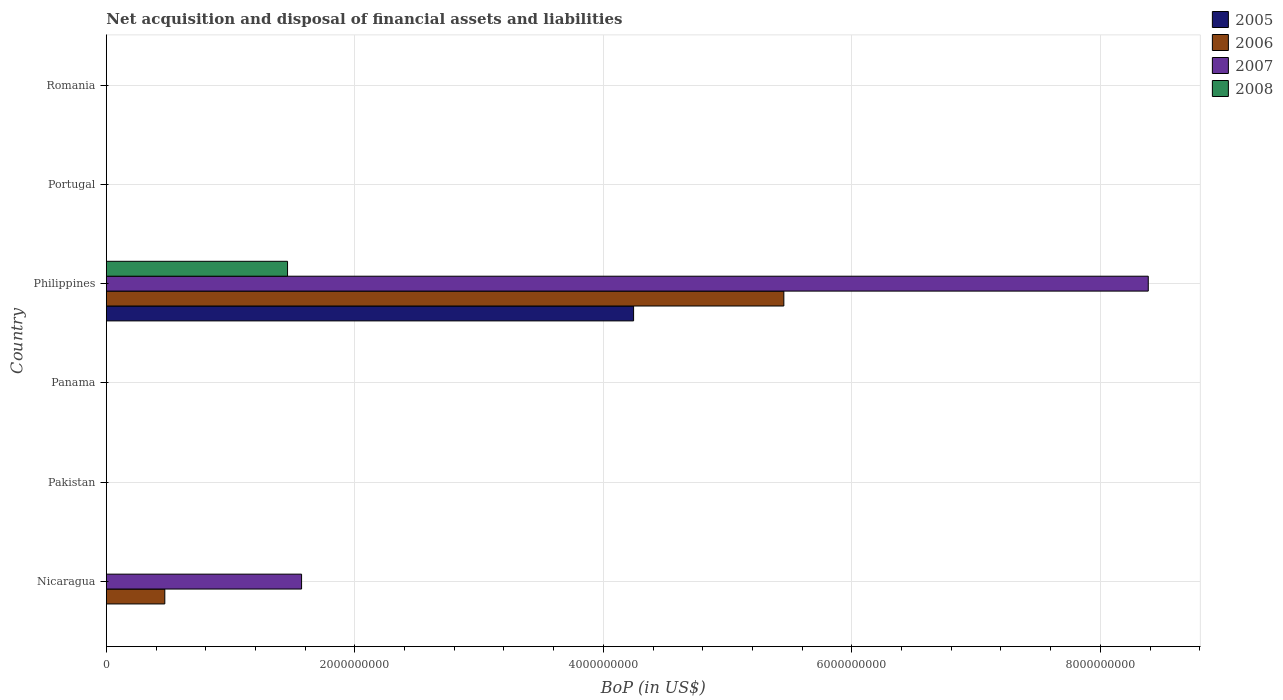Are the number of bars on each tick of the Y-axis equal?
Provide a short and direct response. No. How many bars are there on the 5th tick from the top?
Provide a short and direct response. 0. How many bars are there on the 2nd tick from the bottom?
Offer a very short reply. 0. What is the label of the 6th group of bars from the top?
Ensure brevity in your answer.  Nicaragua. In how many cases, is the number of bars for a given country not equal to the number of legend labels?
Give a very brief answer. 5. What is the Balance of Payments in 2008 in Romania?
Your answer should be very brief. 0. Across all countries, what is the maximum Balance of Payments in 2008?
Your answer should be compact. 1.46e+09. What is the total Balance of Payments in 2006 in the graph?
Offer a very short reply. 5.92e+09. What is the difference between the Balance of Payments in 2008 in Romania and the Balance of Payments in 2005 in Panama?
Offer a terse response. 0. What is the average Balance of Payments in 2006 per country?
Ensure brevity in your answer.  9.87e+08. What is the difference between the Balance of Payments in 2005 and Balance of Payments in 2008 in Philippines?
Provide a short and direct response. 2.79e+09. What is the difference between the highest and the lowest Balance of Payments in 2005?
Your response must be concise. 4.24e+09. In how many countries, is the Balance of Payments in 2007 greater than the average Balance of Payments in 2007 taken over all countries?
Offer a terse response. 1. Is the sum of the Balance of Payments in 2007 in Nicaragua and Philippines greater than the maximum Balance of Payments in 2006 across all countries?
Your answer should be very brief. Yes. How many bars are there?
Provide a short and direct response. 6. What is the difference between two consecutive major ticks on the X-axis?
Offer a very short reply. 2.00e+09. Does the graph contain grids?
Ensure brevity in your answer.  Yes. How many legend labels are there?
Give a very brief answer. 4. What is the title of the graph?
Keep it short and to the point. Net acquisition and disposal of financial assets and liabilities. What is the label or title of the X-axis?
Your answer should be compact. BoP (in US$). What is the BoP (in US$) in 2006 in Nicaragua?
Make the answer very short. 4.71e+08. What is the BoP (in US$) in 2007 in Nicaragua?
Your response must be concise. 1.57e+09. What is the BoP (in US$) in 2006 in Pakistan?
Keep it short and to the point. 0. What is the BoP (in US$) of 2007 in Pakistan?
Your answer should be compact. 0. What is the BoP (in US$) of 2008 in Pakistan?
Your answer should be very brief. 0. What is the BoP (in US$) of 2005 in Panama?
Offer a very short reply. 0. What is the BoP (in US$) of 2007 in Panama?
Offer a terse response. 0. What is the BoP (in US$) of 2005 in Philippines?
Your answer should be compact. 4.24e+09. What is the BoP (in US$) of 2006 in Philippines?
Offer a very short reply. 5.45e+09. What is the BoP (in US$) in 2007 in Philippines?
Provide a short and direct response. 8.39e+09. What is the BoP (in US$) of 2008 in Philippines?
Offer a terse response. 1.46e+09. What is the BoP (in US$) of 2007 in Portugal?
Make the answer very short. 0. What is the BoP (in US$) in 2007 in Romania?
Make the answer very short. 0. What is the BoP (in US$) in 2008 in Romania?
Offer a terse response. 0. Across all countries, what is the maximum BoP (in US$) of 2005?
Offer a very short reply. 4.24e+09. Across all countries, what is the maximum BoP (in US$) of 2006?
Provide a short and direct response. 5.45e+09. Across all countries, what is the maximum BoP (in US$) of 2007?
Provide a succinct answer. 8.39e+09. Across all countries, what is the maximum BoP (in US$) in 2008?
Your response must be concise. 1.46e+09. Across all countries, what is the minimum BoP (in US$) in 2007?
Offer a very short reply. 0. What is the total BoP (in US$) in 2005 in the graph?
Provide a succinct answer. 4.24e+09. What is the total BoP (in US$) in 2006 in the graph?
Your answer should be very brief. 5.92e+09. What is the total BoP (in US$) of 2007 in the graph?
Make the answer very short. 9.96e+09. What is the total BoP (in US$) of 2008 in the graph?
Provide a succinct answer. 1.46e+09. What is the difference between the BoP (in US$) in 2006 in Nicaragua and that in Philippines?
Your answer should be very brief. -4.98e+09. What is the difference between the BoP (in US$) of 2007 in Nicaragua and that in Philippines?
Provide a succinct answer. -6.81e+09. What is the difference between the BoP (in US$) in 2006 in Nicaragua and the BoP (in US$) in 2007 in Philippines?
Make the answer very short. -7.91e+09. What is the difference between the BoP (in US$) in 2006 in Nicaragua and the BoP (in US$) in 2008 in Philippines?
Make the answer very short. -9.88e+08. What is the difference between the BoP (in US$) in 2007 in Nicaragua and the BoP (in US$) in 2008 in Philippines?
Your answer should be compact. 1.13e+08. What is the average BoP (in US$) in 2005 per country?
Your response must be concise. 7.07e+08. What is the average BoP (in US$) in 2006 per country?
Make the answer very short. 9.87e+08. What is the average BoP (in US$) in 2007 per country?
Your answer should be very brief. 1.66e+09. What is the average BoP (in US$) in 2008 per country?
Provide a short and direct response. 2.43e+08. What is the difference between the BoP (in US$) of 2006 and BoP (in US$) of 2007 in Nicaragua?
Provide a short and direct response. -1.10e+09. What is the difference between the BoP (in US$) in 2005 and BoP (in US$) in 2006 in Philippines?
Make the answer very short. -1.21e+09. What is the difference between the BoP (in US$) of 2005 and BoP (in US$) of 2007 in Philippines?
Provide a short and direct response. -4.14e+09. What is the difference between the BoP (in US$) in 2005 and BoP (in US$) in 2008 in Philippines?
Your answer should be very brief. 2.79e+09. What is the difference between the BoP (in US$) of 2006 and BoP (in US$) of 2007 in Philippines?
Keep it short and to the point. -2.93e+09. What is the difference between the BoP (in US$) in 2006 and BoP (in US$) in 2008 in Philippines?
Your response must be concise. 3.99e+09. What is the difference between the BoP (in US$) in 2007 and BoP (in US$) in 2008 in Philippines?
Make the answer very short. 6.93e+09. What is the ratio of the BoP (in US$) of 2006 in Nicaragua to that in Philippines?
Offer a very short reply. 0.09. What is the ratio of the BoP (in US$) in 2007 in Nicaragua to that in Philippines?
Provide a succinct answer. 0.19. What is the difference between the highest and the lowest BoP (in US$) in 2005?
Offer a terse response. 4.24e+09. What is the difference between the highest and the lowest BoP (in US$) of 2006?
Provide a short and direct response. 5.45e+09. What is the difference between the highest and the lowest BoP (in US$) in 2007?
Your answer should be compact. 8.39e+09. What is the difference between the highest and the lowest BoP (in US$) of 2008?
Make the answer very short. 1.46e+09. 